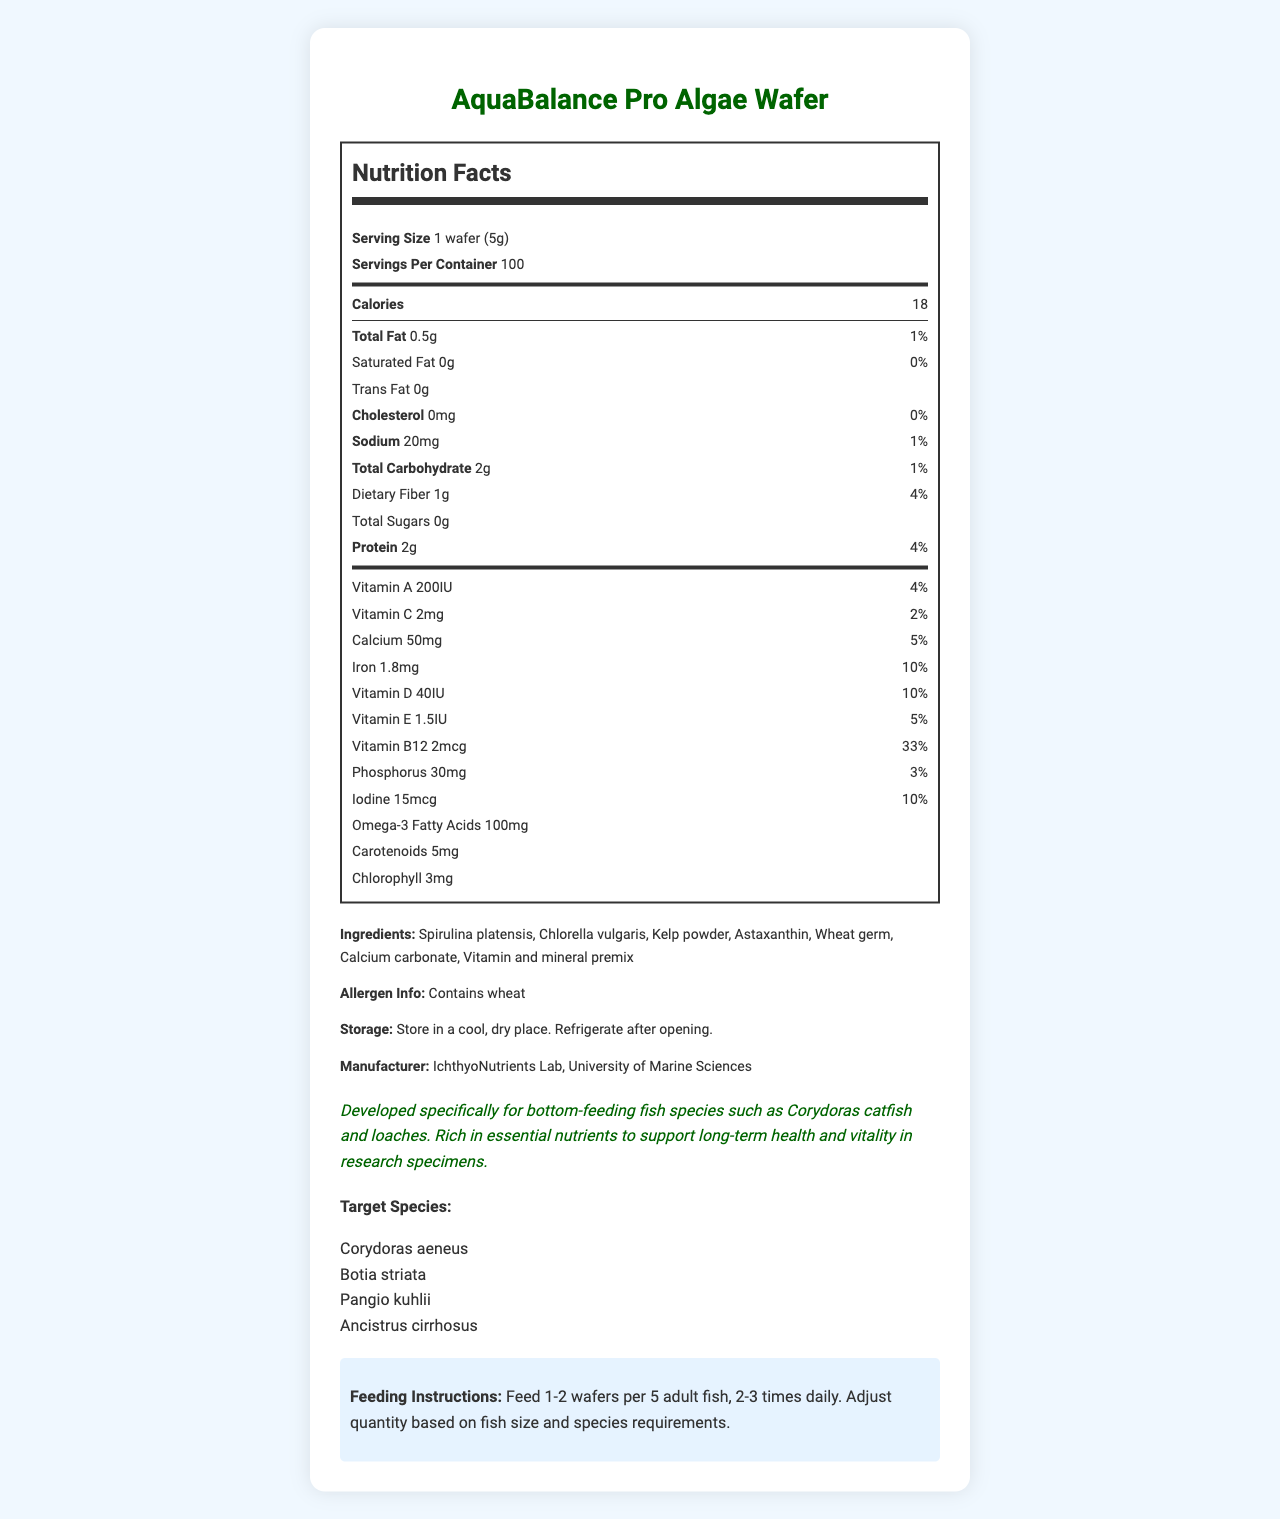1. What is the serving size of AquaBalance Pro Algae Wafer? The document states that the serving size is 1 wafer, which weighs 5 grams.
Answer: 1 wafer (5g) 2. How many servings are there per container? The document lists 100 servings per container.
Answer: 100 3. How many calories are in one serving of the algae wafer? The document indicates that there are 18 calories per serving.
Answer: 18 4. What is the total amount of protein in one serving of AquaBalance Pro Algae Wafer? The nutrition facts section shows that there are 2 grams of protein per serving.
Answer: 2g 5. Name two vitamins present in AquaBalance Pro Algae Wafer. The document lists both Vitamin A (200IU) and Vitamin C (2mg) under the micronutrient section.
Answer: Vitamin A and Vitamin C 6. What percentage of the daily value of iron does one serving provide? The document indicates that one serving contains 1.8mg of iron, which is 10% of the daily value.
Answer: 10% 7. List all ingredients found in AquaBalance Pro Algae Wafer. The ingredients section of the document lists all these items.
Answer: Spirulina platensis, Chlorella vulgaris, Kelp powder, Astaxanthin, Wheat germ, Calcium carbonate, Vitamin and mineral premix 8. Which of the following species is a target species for this product? 
   A. Pterophyllum scalare
   B. Corydoras aeneus
   C. Poecilia reticulata The document lists Corydoras aeneus as a target species.
Answer: B. Corydoras aeneus 9. How much saturated fat is present in one serving? The nutrition facts section shows that there is 0 grams of saturated fat per serving.
Answer: 0g 10. What are the recommended storage instructions for the product? The storage instructions specify to store in a cool, dry place and refrigerate after opening.
Answer: Store in a cool, dry place. Refrigerate after opening. 11. Does the product contain any allergens? The allergen information indicates that the product contains wheat.
Answer: Yes 12. How much calcium is there in one wafer, and what is its daily value percentage? The document states that one wafer contains 50mg of calcium, which is 5% of the daily value.
Answer: 50mg, 5% 13. Based on one serving, which nutrient has the highest daily value percentage? 
    A. Vitamin B12 
    B. Iron 
    C. Vitamin A The daily value percentage for Vitamin B12 is 33%, which is higher than Iron (10%) and Vitamin A (4%).
Answer: A. Vitamin B12 14. True or False: The product is designed for top-feeding fish species. The research notes clearly state that the product is developed specifically for bottom-feeding fish species.
Answer: False 15. Who is the manufacturer of AquaBalance Pro Algae Wafer? The manufacturer section lists IchthyoNutrients Lab, University of Marine Sciences as the producer.
Answer: IchthyoNutrients Lab, University of Marine Sciences 16. Describe the main idea of the document. The document outlines the composition, benefits, and usage instructions for AquaBalance Pro Algae Wafer, emphasizing its suitability for research specimens.
Answer: The document provides detailed information about AquaBalance Pro Algae Wafer, a nutrient-rich food developed for bottom-feeding fish in research aquariums. It includes nutritional facts, ingredients, storage instructions, target species, and feeding instructions. 17. What is the research note about this product? The research notes highlight that the product is specifically designed for bottom-feeding fish and is rich in essential nutrients to support their health and vitality.
Answer: Developed specifically for bottom-feeding fish species such as Corydoras catfish and loaches. Rich in essential nutrients to support long-term health and vitality in research specimens. 18. What is the sodium content in one serving, and how does it compare to the daily value? One serving contains 20mg of sodium, which is 1% of the daily value.
Answer: 20mg, 1% 19. How many milligrams of chlorophyll are in each serving of the algae wafer? The nutrition facts section lists that each serving contains 3mg of chlorophyll.
Answer: 3mg 20. What is the purpose of the vitamin and mineral premix in the ingredients? The document does not provide specific details on the purpose of the vitamin and mineral premix beyond its inclusion in the ingredients.
Answer: Not enough information 